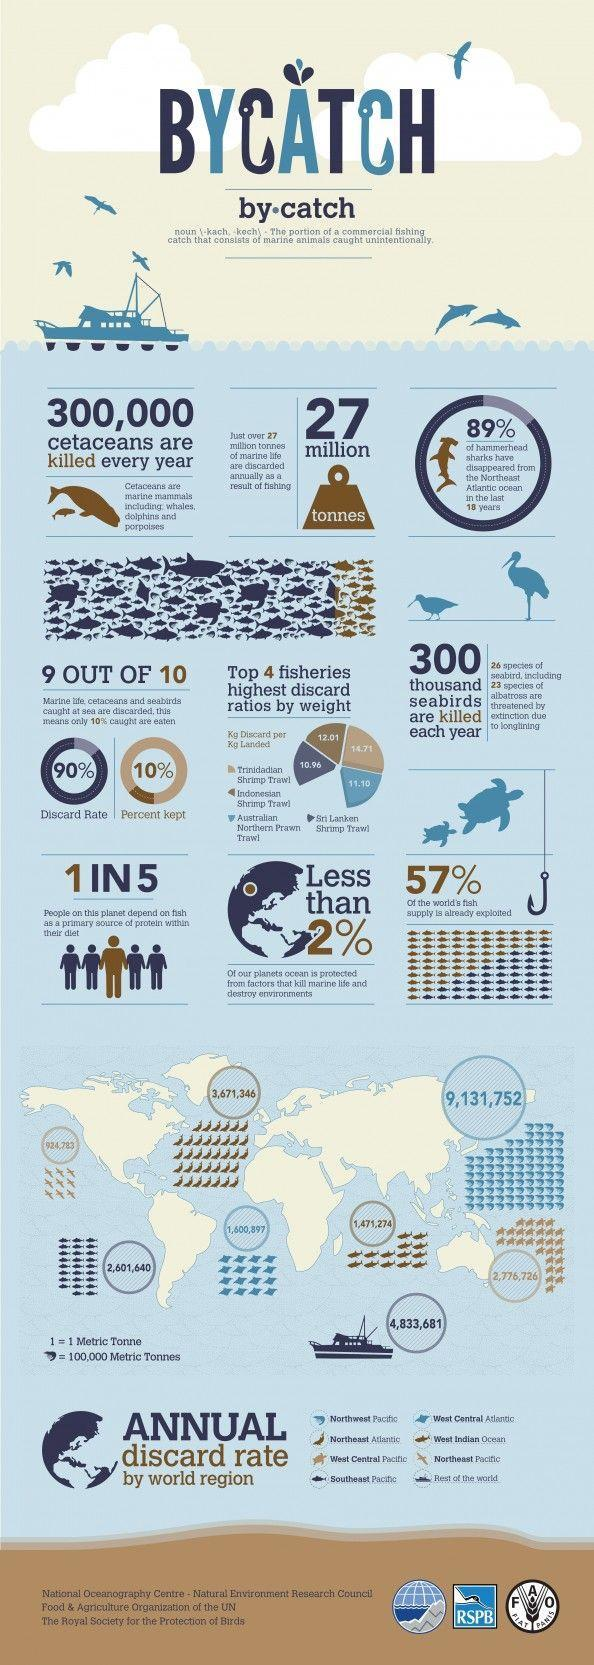What percentage of the world's fish supply not exploited?
Answer the question with a short phrase. 43% 